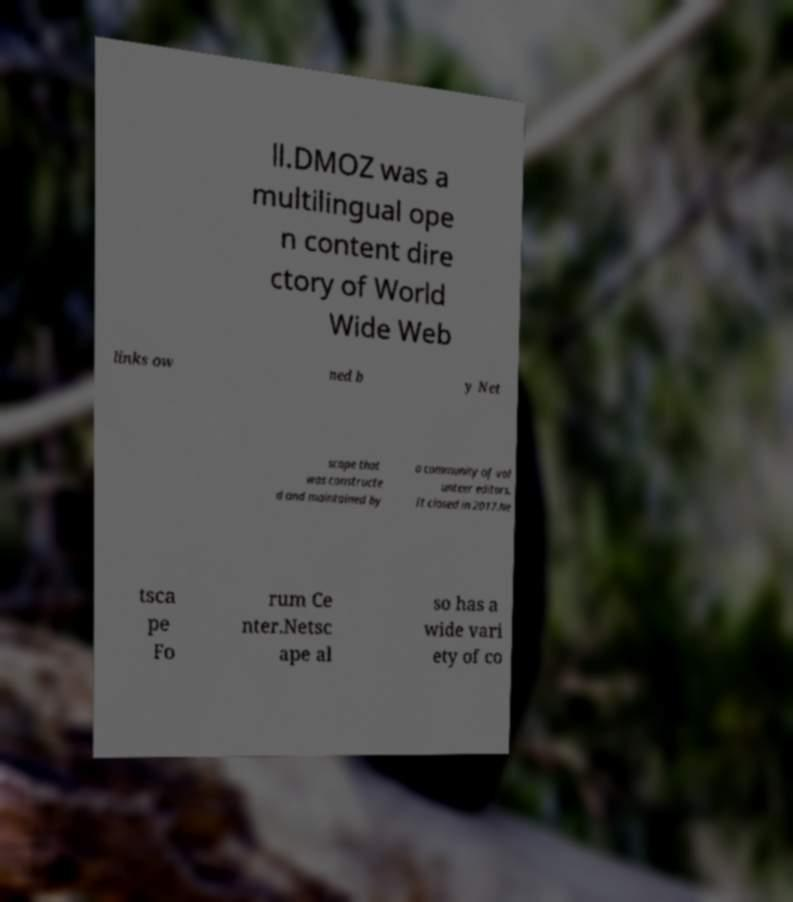I need the written content from this picture converted into text. Can you do that? ll.DMOZ was a multilingual ope n content dire ctory of World Wide Web links ow ned b y Net scape that was constructe d and maintained by a community of vol unteer editors. It closed in 2017.Ne tsca pe Fo rum Ce nter.Netsc ape al so has a wide vari ety of co 